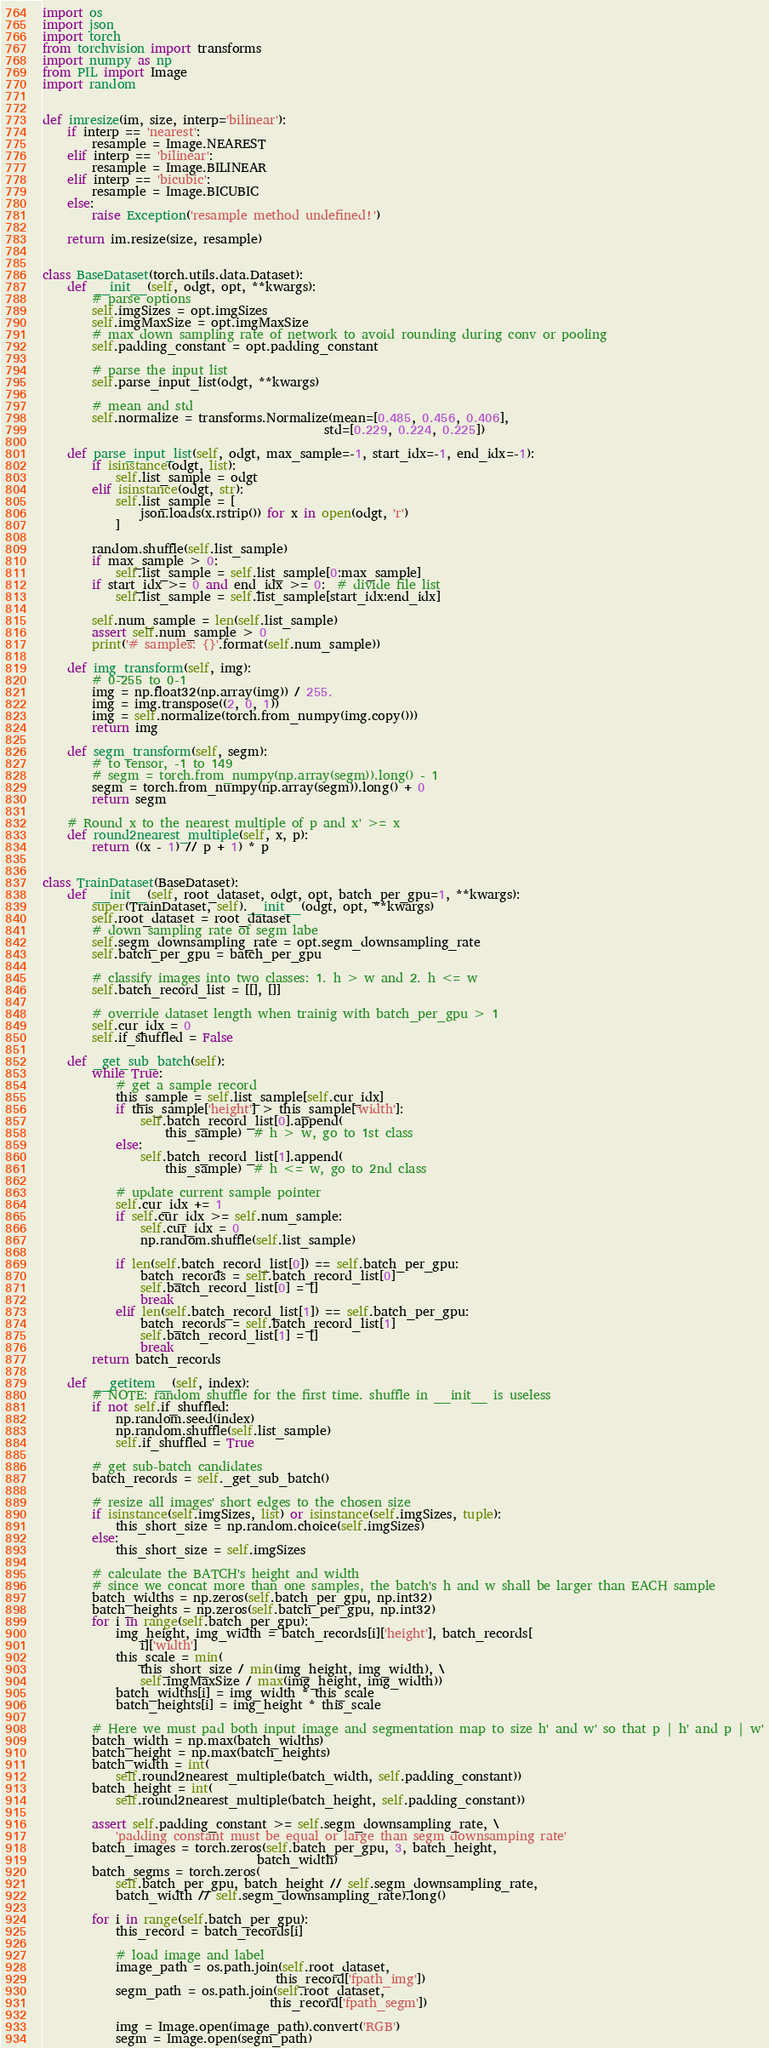Convert code to text. <code><loc_0><loc_0><loc_500><loc_500><_Python_>import os
import json
import torch
from torchvision import transforms
import numpy as np
from PIL import Image
import random


def imresize(im, size, interp='bilinear'):
    if interp == 'nearest':
        resample = Image.NEAREST
    elif interp == 'bilinear':
        resample = Image.BILINEAR
    elif interp == 'bicubic':
        resample = Image.BICUBIC
    else:
        raise Exception('resample method undefined!')

    return im.resize(size, resample)


class BaseDataset(torch.utils.data.Dataset):
    def __init__(self, odgt, opt, **kwargs):
        # parse options
        self.imgSizes = opt.imgSizes
        self.imgMaxSize = opt.imgMaxSize
        # max down sampling rate of network to avoid rounding during conv or pooling
        self.padding_constant = opt.padding_constant

        # parse the input list
        self.parse_input_list(odgt, **kwargs)

        # mean and std
        self.normalize = transforms.Normalize(mean=[0.485, 0.456, 0.406],
                                              std=[0.229, 0.224, 0.225])

    def parse_input_list(self, odgt, max_sample=-1, start_idx=-1, end_idx=-1):
        if isinstance(odgt, list):
            self.list_sample = odgt
        elif isinstance(odgt, str):
            self.list_sample = [
                json.loads(x.rstrip()) for x in open(odgt, 'r')
            ]

        random.shuffle(self.list_sample)
        if max_sample > 0:
            self.list_sample = self.list_sample[0:max_sample]
        if start_idx >= 0 and end_idx >= 0:  # divide file list
            self.list_sample = self.list_sample[start_idx:end_idx]

        self.num_sample = len(self.list_sample)
        assert self.num_sample > 0
        print('# samples: {}'.format(self.num_sample))

    def img_transform(self, img):
        # 0-255 to 0-1
        img = np.float32(np.array(img)) / 255.
        img = img.transpose((2, 0, 1))
        img = self.normalize(torch.from_numpy(img.copy()))
        return img

    def segm_transform(self, segm):
        # to tensor, -1 to 149
        # segm = torch.from_numpy(np.array(segm)).long() - 1
        segm = torch.from_numpy(np.array(segm)).long() + 0
        return segm

    # Round x to the nearest multiple of p and x' >= x
    def round2nearest_multiple(self, x, p):
        return ((x - 1) // p + 1) * p


class TrainDataset(BaseDataset):
    def __init__(self, root_dataset, odgt, opt, batch_per_gpu=1, **kwargs):
        super(TrainDataset, self).__init__(odgt, opt, **kwargs)
        self.root_dataset = root_dataset
        # down sampling rate of segm labe
        self.segm_downsampling_rate = opt.segm_downsampling_rate
        self.batch_per_gpu = batch_per_gpu

        # classify images into two classes: 1. h > w and 2. h <= w
        self.batch_record_list = [[], []]

        # override dataset length when trainig with batch_per_gpu > 1
        self.cur_idx = 0
        self.if_shuffled = False

    def _get_sub_batch(self):
        while True:
            # get a sample record
            this_sample = self.list_sample[self.cur_idx]
            if this_sample['height'] > this_sample['width']:
                self.batch_record_list[0].append(
                    this_sample)  # h > w, go to 1st class
            else:
                self.batch_record_list[1].append(
                    this_sample)  # h <= w, go to 2nd class

            # update current sample pointer
            self.cur_idx += 1
            if self.cur_idx >= self.num_sample:
                self.cur_idx = 0
                np.random.shuffle(self.list_sample)

            if len(self.batch_record_list[0]) == self.batch_per_gpu:
                batch_records = self.batch_record_list[0]
                self.batch_record_list[0] = []
                break
            elif len(self.batch_record_list[1]) == self.batch_per_gpu:
                batch_records = self.batch_record_list[1]
                self.batch_record_list[1] = []
                break
        return batch_records

    def __getitem__(self, index):
        # NOTE: random shuffle for the first time. shuffle in __init__ is useless
        if not self.if_shuffled:
            np.random.seed(index)
            np.random.shuffle(self.list_sample)
            self.if_shuffled = True

        # get sub-batch candidates
        batch_records = self._get_sub_batch()

        # resize all images' short edges to the chosen size
        if isinstance(self.imgSizes, list) or isinstance(self.imgSizes, tuple):
            this_short_size = np.random.choice(self.imgSizes)
        else:
            this_short_size = self.imgSizes

        # calculate the BATCH's height and width
        # since we concat more than one samples, the batch's h and w shall be larger than EACH sample
        batch_widths = np.zeros(self.batch_per_gpu, np.int32)
        batch_heights = np.zeros(self.batch_per_gpu, np.int32)
        for i in range(self.batch_per_gpu):
            img_height, img_width = batch_records[i]['height'], batch_records[
                i]['width']
            this_scale = min(
                this_short_size / min(img_height, img_width), \
                self.imgMaxSize / max(img_height, img_width))
            batch_widths[i] = img_width * this_scale
            batch_heights[i] = img_height * this_scale

        # Here we must pad both input image and segmentation map to size h' and w' so that p | h' and p | w'
        batch_width = np.max(batch_widths)
        batch_height = np.max(batch_heights)
        batch_width = int(
            self.round2nearest_multiple(batch_width, self.padding_constant))
        batch_height = int(
            self.round2nearest_multiple(batch_height, self.padding_constant))

        assert self.padding_constant >= self.segm_downsampling_rate, \
            'padding constant must be equal or large than segm downsamping rate'
        batch_images = torch.zeros(self.batch_per_gpu, 3, batch_height,
                                   batch_width)
        batch_segms = torch.zeros(
            self.batch_per_gpu, batch_height // self.segm_downsampling_rate,
            batch_width // self.segm_downsampling_rate).long()

        for i in range(self.batch_per_gpu):
            this_record = batch_records[i]

            # load image and label
            image_path = os.path.join(self.root_dataset,
                                      this_record['fpath_img'])
            segm_path = os.path.join(self.root_dataset,
                                     this_record['fpath_segm'])

            img = Image.open(image_path).convert('RGB')
            segm = Image.open(segm_path)</code> 